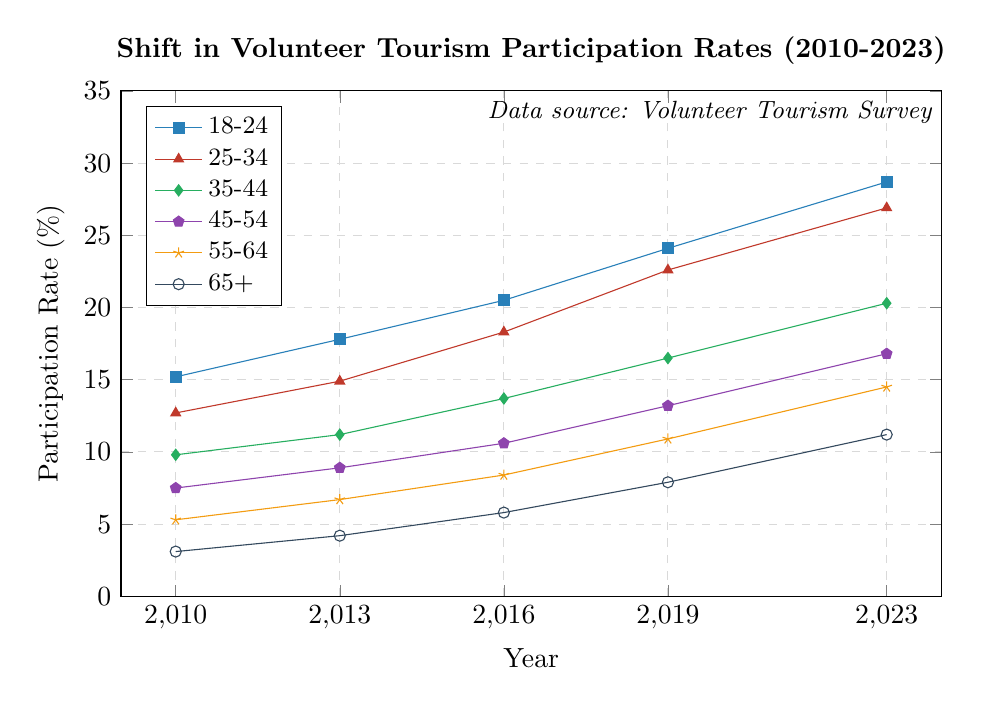What is the overall trend for the 18-24 age group from 2010 to 2023? The participation rate for the 18-24 age group has consistently increased over the years. Starting at 15.2% in 2010, it has risen to 28.7% by 2023.
Answer: Increasing Which age group has the lowest participation rate in 2023? In 2023, the 65+ age group has the lowest participation rate at 11.2%.
Answer: 65+ By how much did the participation rate for the 55-64 age group increase from 2010 to 2023? The participation rate for the 55-64 age group was 5.3% in 2010 and increased to 14.5% in 2023. The increase is 14.5% - 5.3% = 9.2%.
Answer: 9.2% Between 2016 and 2023, which age group experienced the highest growth in participation rate? The 18-24 age group had the highest growth in participation rate between 2016 and 2023, increasing from 20.5% to 28.7%. The growth is 28.7% - 20.5% = 8.2%.
Answer: 18-24 What is the combined participation rate for all age groups in 2010? Summing the rates for all age groups in 2010: 15.2% + 12.7% + 9.8% + 7.5% + 5.3% + 3.1% = 53.6%.
Answer: 53.6% Which age group had the highest participation rate in 2019? The 18-24 age group had the highest participation rate in 2019 at 24.1%.
Answer: 18-24 What is the difference in participation rates between the 25-34 age group and the 45-54 age group in 2023? The participation rate for the 25-34 age group in 2023 is 26.9%, and for the 45-54 age group, it is 16.8%. The difference is 26.9% - 16.8% = 10.1%.
Answer: 10.1% Which age group showed the least change in participation rate between 2010 and 2023? The 65+ age group had the smallest change in participation rate from 3.1% in 2010 to 11.2% in 2023, a change of 11.2% - 3.1% = 8.1%.
Answer: 65+ What is the average participation rate for the 35-44 age group across the years? The participation rates for the 35-44 age group in each year are 9.8%, 11.2%, 13.7%, 16.5%, and 20.3%. The average rate is (9.8 + 11.2 + 13.7 + 16.5 + 20.3)/5 = 14.3%.
Answer: 14.3% How many age groups had a participation rate above 10% in 2016? In 2016, the age groups with participation rates above 10% were 18-24 (20.5%), 25-34 (18.3%), 35-44 (13.7%), and 45-54 (10.6%). Thus, 4 age groups had rates above 10%.
Answer: 4 